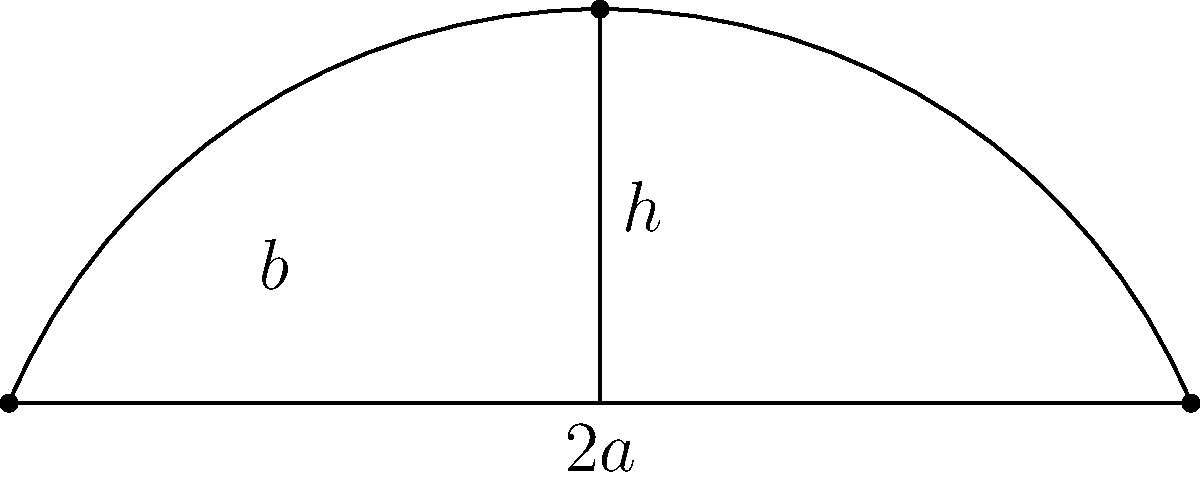As an outdoor furniture designer, you're creating a curved bench seat. The seat's shape can be approximated by an arc of a parabola with a base length of $6$ meters and a height of $2$ meters at its center. If the width of the bench seat is $1.5$ meters, calculate the surface area of the seat. Round your answer to the nearest 0.01 square meters. To calculate the surface area of the curved bench seat, we'll follow these steps:

1) The shape of the seat is described by a parabolic arc. We can use the arc length formula for a parabola to find the length of the curved part.

2) The arc length formula for a parabola $y = kx^2$ from $x = -a$ to $x = a$ is:

   $$L = \frac{a}{2k}\left[\sqrt{1+4k^2a^2} + \frac{\ln(2ka + \sqrt{1+4k^2a^2})}{k}\right]$$

3) In our case, $a = 3$ (half of the base length) and $h = 2$. We need to find $k$.

4) For a parabola $y = kx^2$, when $x = a$, $y = h$. So:
   
   $2 = k(3)^2$
   $k = \frac{2}{9}$

5) Now we can substitute into the arc length formula:

   $$L = \frac{3}{2(\frac{2}{9})}\left[\sqrt{1+4(\frac{2}{9})^2(3)^2} + \frac{\ln(2(\frac{2}{9})(3) + \sqrt{1+4(\frac{2}{9})^2(3)^2})}{(\frac{2}{9})}\right]$$

6) Simplifying:

   $$L = \frac{27}{4}\left[\sqrt{1+\frac{4}{9}} + \frac{9}{2}\ln(1.333 + 1.491)\right] \approx 6.85$$

7) The surface area is the product of this arc length and the width of the bench:

   $\text{Area} = 6.85 \times 1.5 = 10.275$ square meters

8) Rounding to the nearest 0.01:

   $\text{Area} \approx 10.28$ square meters
Answer: 10.28 m² 